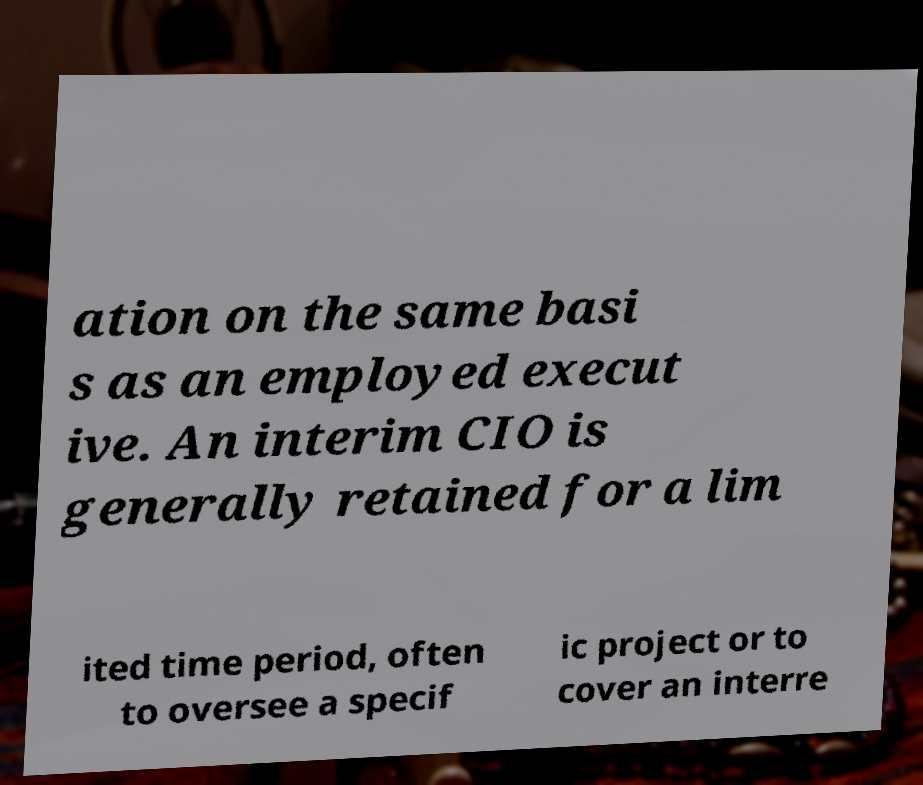Please identify and transcribe the text found in this image. ation on the same basi s as an employed execut ive. An interim CIO is generally retained for a lim ited time period, often to oversee a specif ic project or to cover an interre 